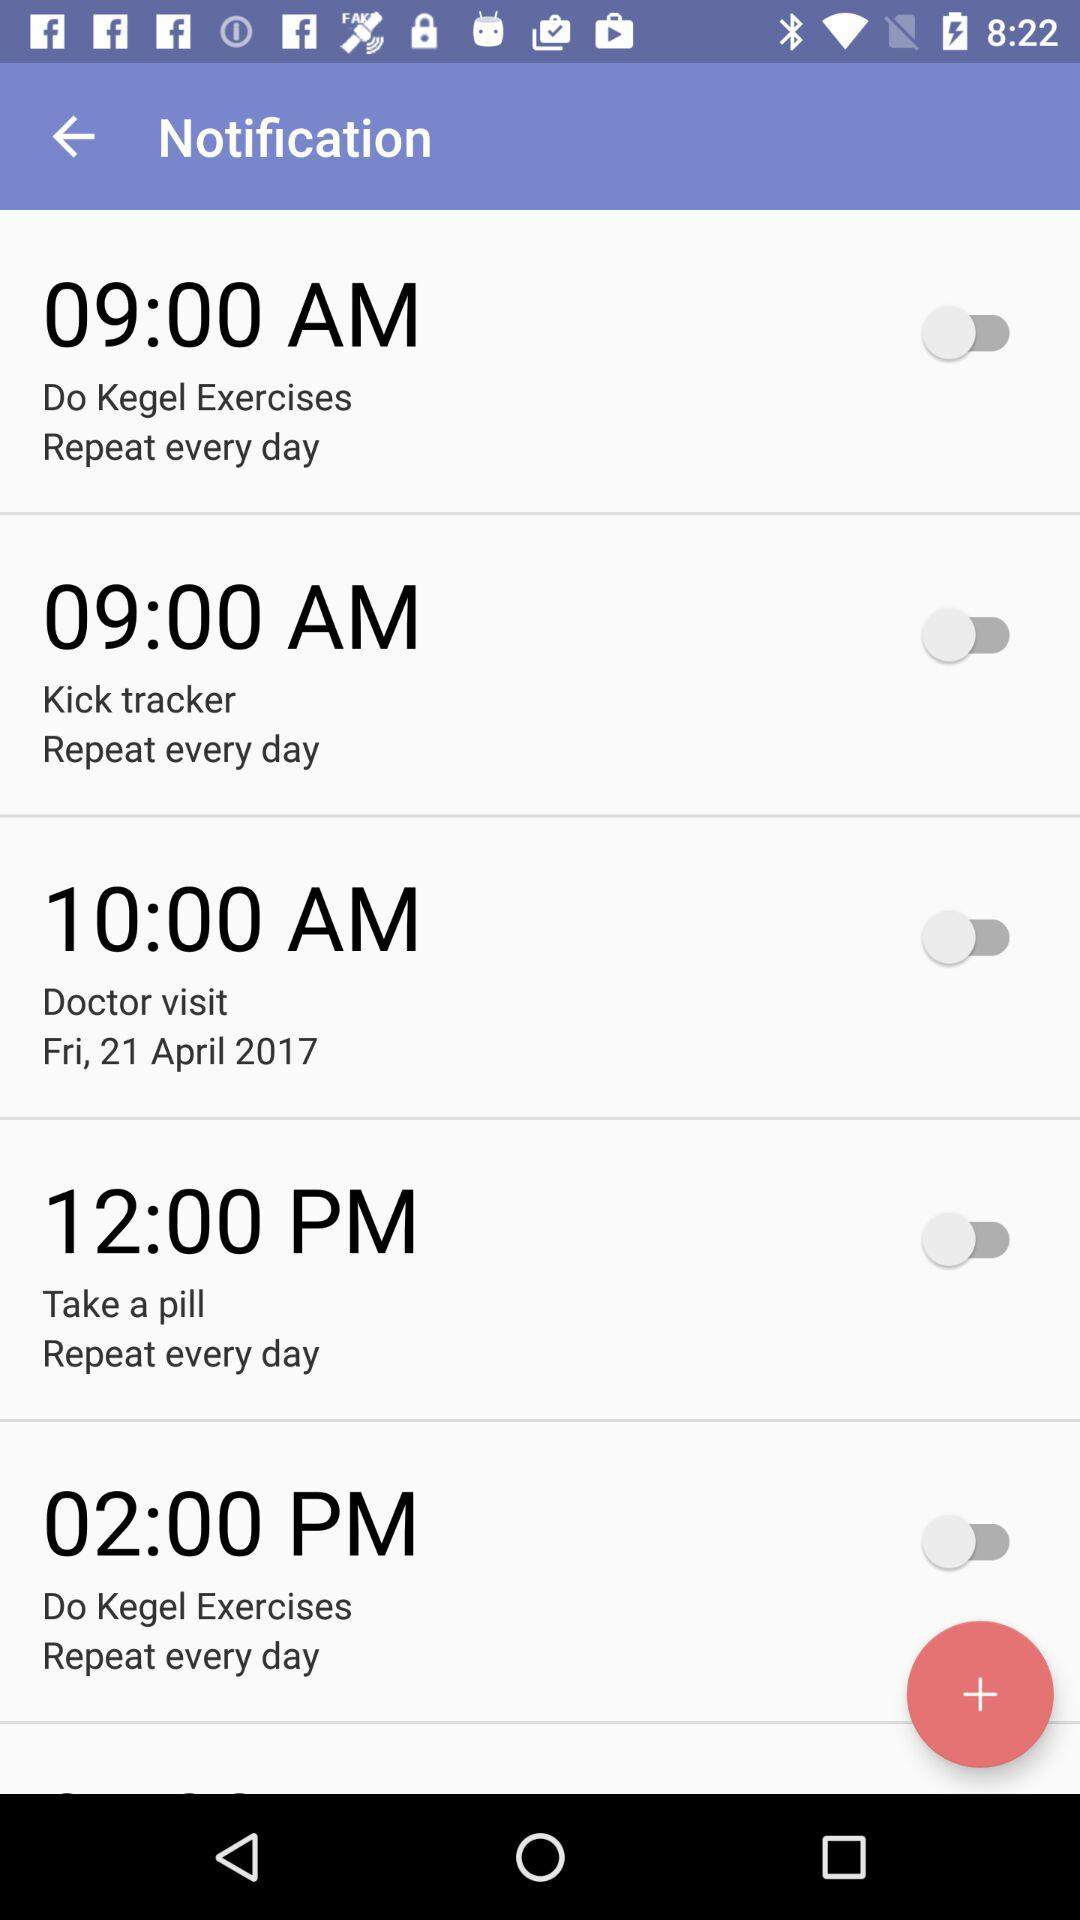What time is selected for the "Do Kegel Exercises"? The selected time is 9:00 AM. 